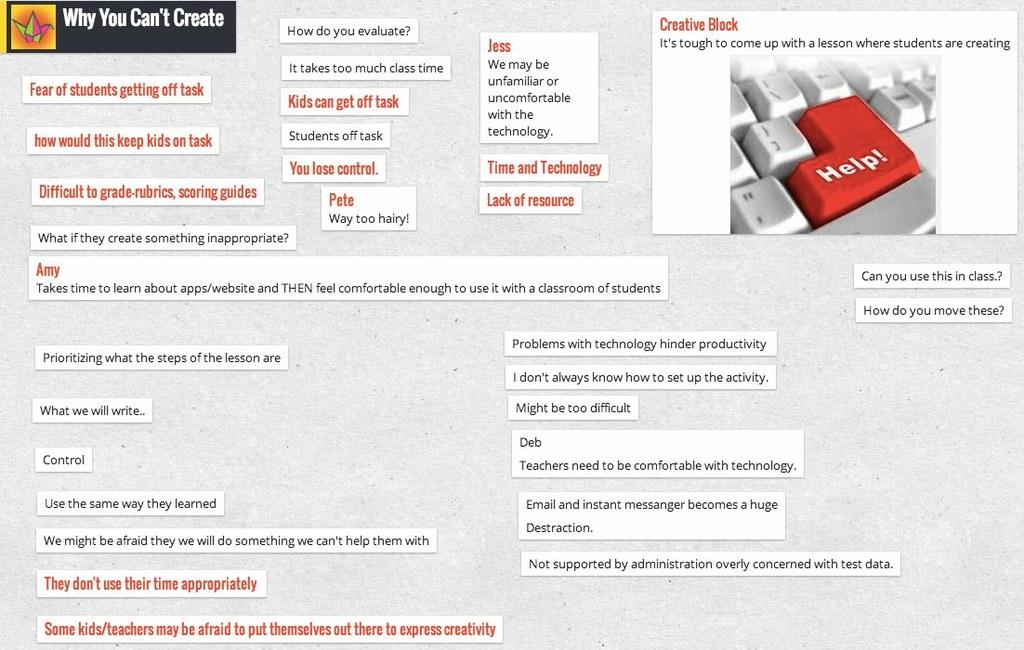What is written in the red button?
Provide a succinct answer. Help!. 